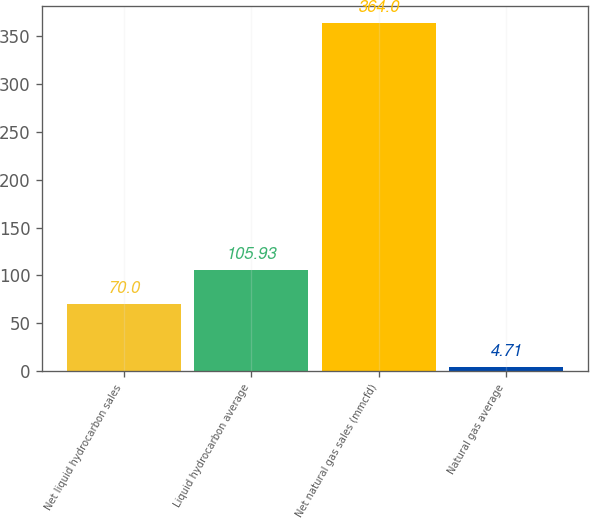Convert chart to OTSL. <chart><loc_0><loc_0><loc_500><loc_500><bar_chart><fcel>Net liquid hydrocarbon sales<fcel>Liquid hydrocarbon average<fcel>Net natural gas sales (mmcfd)<fcel>Natural gas average<nl><fcel>70<fcel>105.93<fcel>364<fcel>4.71<nl></chart> 